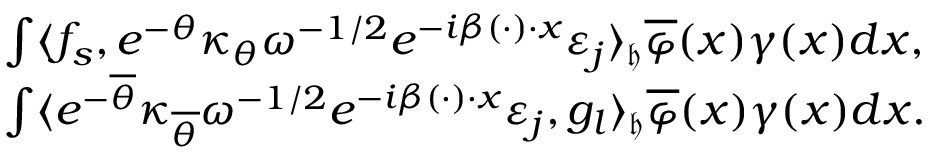Convert formula to latex. <formula><loc_0><loc_0><loc_500><loc_500>\begin{array} { r l } & { \int \langle f _ { s } , e ^ { - \theta } \kappa _ { \theta } \omega ^ { - 1 / 2 } e ^ { - i \beta ( \cdot ) \cdot x } \varepsilon _ { j } \rangle _ { \mathfrak { h } } \overline { \varphi } ( x ) \gamma ( x ) d x , } \\ & { \int \langle e ^ { - \overline { \theta } } \kappa _ { \overline { \theta } } \omega ^ { - 1 / 2 } e ^ { - i \beta ( \cdot ) \cdot x } \varepsilon _ { j } , { g } _ { l } \rangle _ { \mathfrak { h } } \overline { \varphi } ( x ) \gamma ( x ) d x . } \end{array}</formula> 